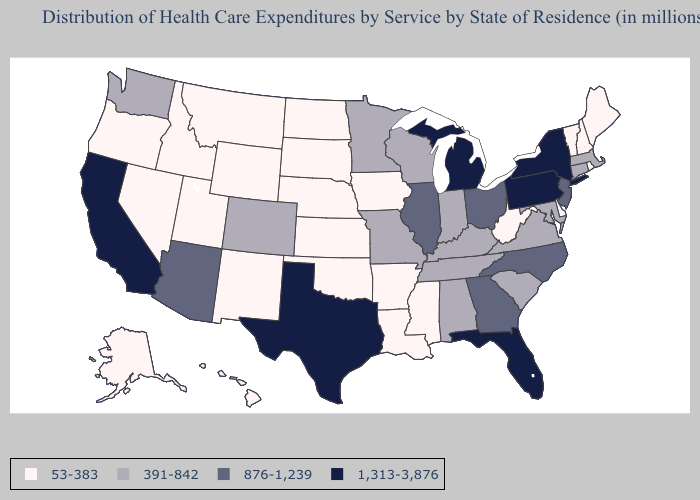What is the lowest value in the South?
Keep it brief. 53-383. What is the lowest value in the Northeast?
Concise answer only. 53-383. Among the states that border New Hampshire , which have the lowest value?
Be succinct. Maine, Vermont. Name the states that have a value in the range 1,313-3,876?
Write a very short answer. California, Florida, Michigan, New York, Pennsylvania, Texas. How many symbols are there in the legend?
Answer briefly. 4. Among the states that border South Dakota , does Minnesota have the highest value?
Write a very short answer. Yes. What is the value of Georgia?
Concise answer only. 876-1,239. What is the highest value in the USA?
Short answer required. 1,313-3,876. Does Mississippi have a lower value than Colorado?
Short answer required. Yes. Name the states that have a value in the range 876-1,239?
Short answer required. Arizona, Georgia, Illinois, New Jersey, North Carolina, Ohio. What is the value of New York?
Quick response, please. 1,313-3,876. Name the states that have a value in the range 1,313-3,876?
Keep it brief. California, Florida, Michigan, New York, Pennsylvania, Texas. What is the lowest value in the South?
Write a very short answer. 53-383. Which states have the lowest value in the USA?
Be succinct. Alaska, Arkansas, Delaware, Hawaii, Idaho, Iowa, Kansas, Louisiana, Maine, Mississippi, Montana, Nebraska, Nevada, New Hampshire, New Mexico, North Dakota, Oklahoma, Oregon, Rhode Island, South Dakota, Utah, Vermont, West Virginia, Wyoming. Does the map have missing data?
Be succinct. No. 